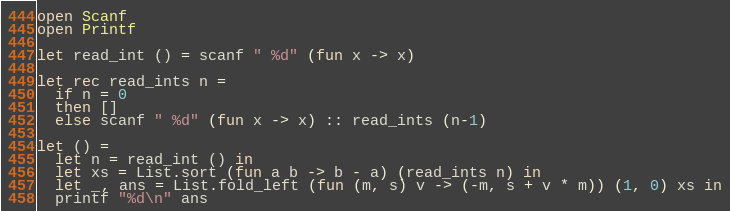<code> <loc_0><loc_0><loc_500><loc_500><_OCaml_>
open Scanf
open Printf

let read_int () = scanf " %d" (fun x -> x)

let rec read_ints n =
  if n = 0
  then []
  else scanf " %d" (fun x -> x) :: read_ints (n-1)

let () =
  let n = read_int () in
  let xs = List.sort (fun a b -> b - a) (read_ints n) in
  let _, ans = List.fold_left (fun (m, s) v -> (-m, s + v * m)) (1, 0) xs in
  printf "%d\n" ans
</code> 